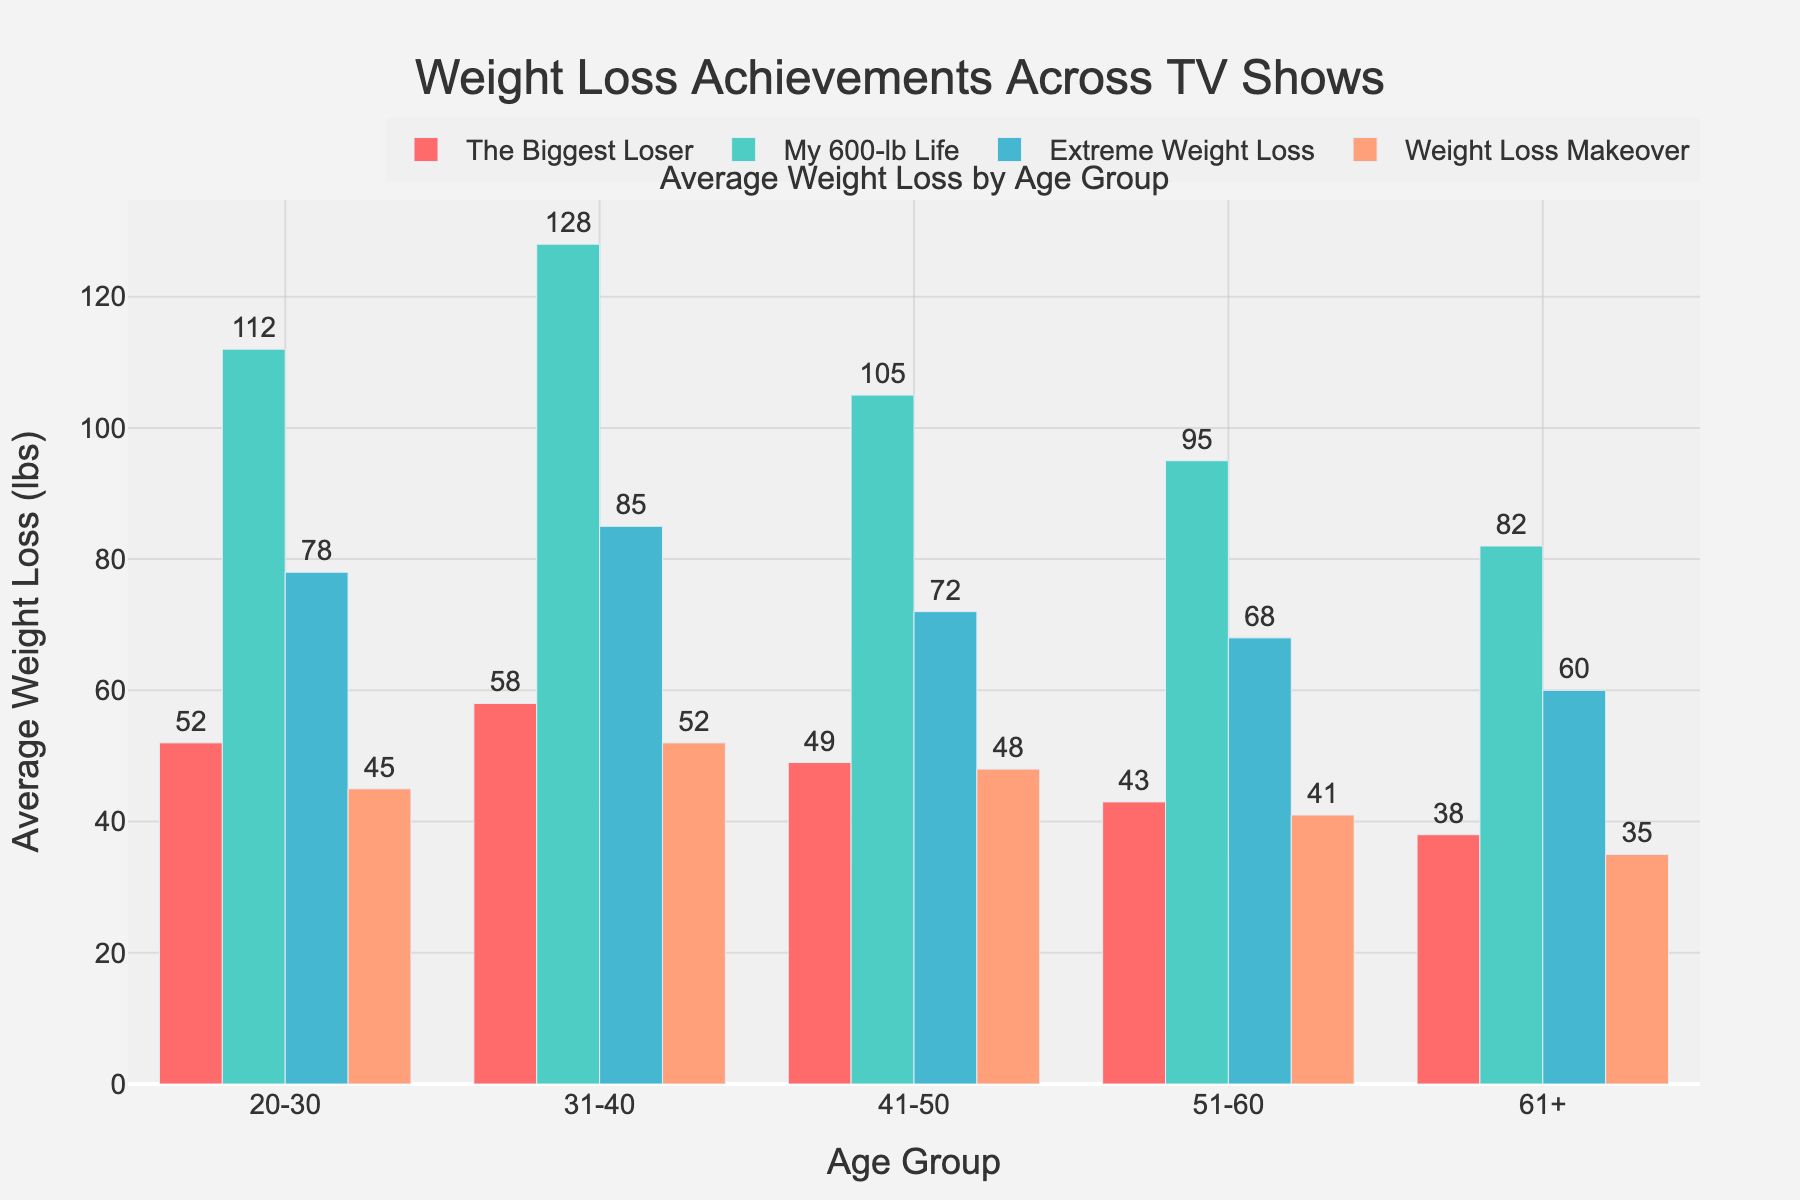What age group achieved the highest average weight loss on "My 600-lb Life"? The 31-40 age group achieved the highest average weight loss, which is shown by the tallest bar among all the age groups for "My 600-lb Life". The figure indicates 128 lbs.
Answer: 31-40 How much more weight did the 31-40 age group lose compared to the 61+ age group on "The Biggest Loser"? Looking at "The Biggest Loser" bars, the 31-40 age group lost 58 lbs, while the 61+ age group lost 38 lbs. The difference is 58 - 38 = 20 lbs.
Answer: 20 lbs Which TV show resulted in the lowest average weight loss for participants aged 20-30? For the age group 20-30, the smallest bar height is for the "Weight Loss Makeover" show, indicating 45 lbs.
Answer: Weight Loss Makeover What's the total weight loss achieved by participants in the 41-50 age group across all shows? Summarizing the bars for the 41-50 age group: "The Biggest Loser" (49 lbs), "My 600-lb Life" (105 lbs), "Extreme Weight Loss" (72 lbs), and "Weight Loss Makeover" (48 lbs). Adding them gives 49 + 105 + 72 + 48 = 274 lbs.
Answer: 274 lbs What is the average weight loss for the 51-60 age group across all shows? To find the average, add the weights for the age group 51-60 across all shows: 43 ("The Biggest Loser") + 95 ("My 600-lb Life") + 68 ("Extreme Weight Loss") + 41 ("Weight Loss Makeover") = 247 lbs. The average is 247 / 4 = 61.75 lbs.
Answer: 61.75 lbs Compare the weight loss in the "Extreme Weight Loss" show for the age groups 20-30 and 31-40. Which group lost more weight and by how much? The 20-30 age group lost 78 lbs and the 31-40 age group lost 85 lbs in "Extreme Weight Loss". The difference is 85 - 78 = 7 lbs, with the 31-40 group losing more.
Answer: 31-40 by 7 lbs Which age group had the most varied weight loss outcomes across all TV shows? The "My 600-lb Life" shows wide variability in weight loss; by calculating the range (maximum - minimum) for each age group, we find the 31-40 age group had the most variance as its maximum (128 lbs) and minimum (41 lbs) across the shows gives 87 lbs.
Answer: 31-40 What is the sum of weight loss achieved by participants aged 61+ on "The Biggest Loser" and "Weight Loss Makeover"? For the 61+ age group, calculate the sum as follows: 38 (Biggest Loser) + 35 (Weight Loss Makeover) = 73 lbs.
Answer: 73 lbs Which TV show leads to the most consistent average weight loss across all age groups? Observing the bars of similar heights across age groups, "Weight Loss Makeover" shows more consistent values (ranging from 35 to 52 lbs without large variations).
Answer: Weight Loss Makeover 